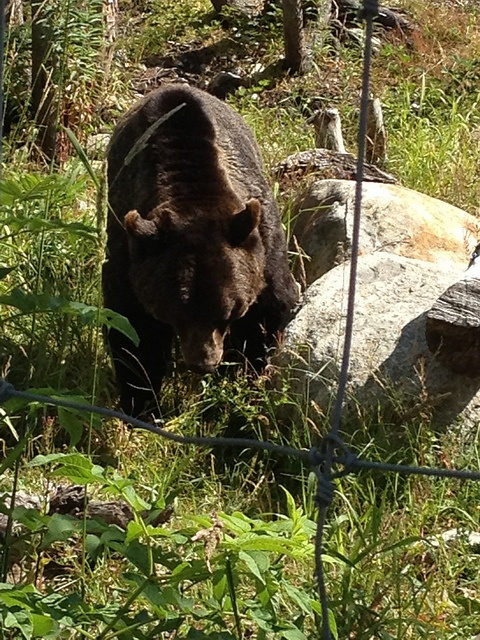Describe the objects in this image and their specific colors. I can see a bear in black, gray, olive, and tan tones in this image. 